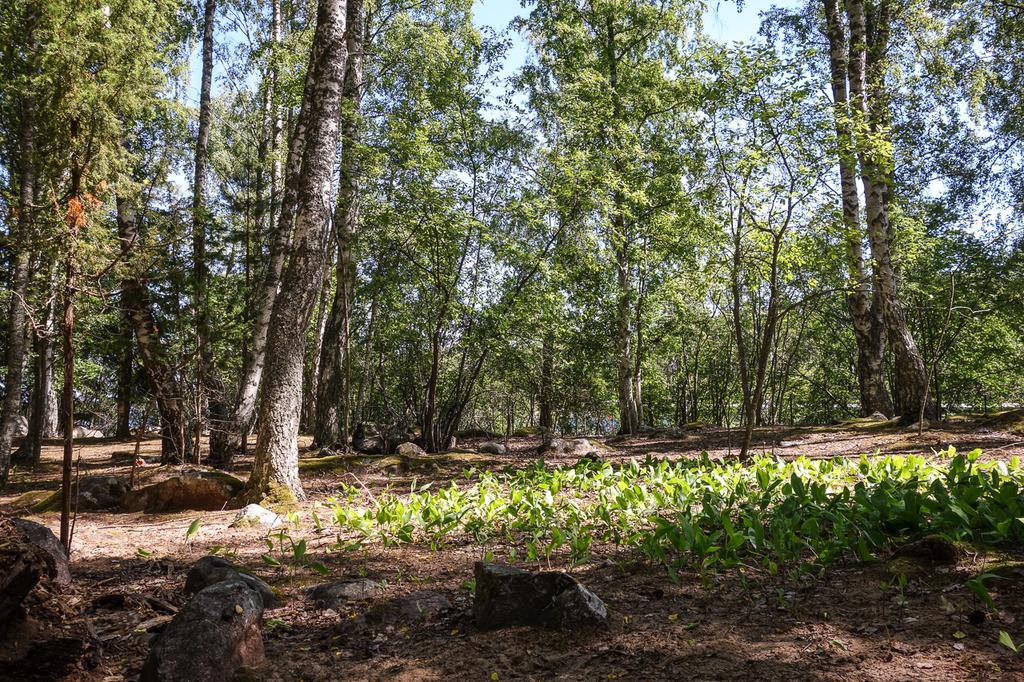What is the main feature in the center of the image? There are many trees in the center of the image. What can be seen at the bottom of the image? Small plants and rocks are visible at the bottom of the image. What is visible in the background of the image? There is a sky visible in the background of the image. How many chickens are sitting on the rocks in the image? There are no chickens present in the image; it features trees, small plants, rocks, and a sky. What type of bomb can be seen in the image? There is no bomb present in the image. 